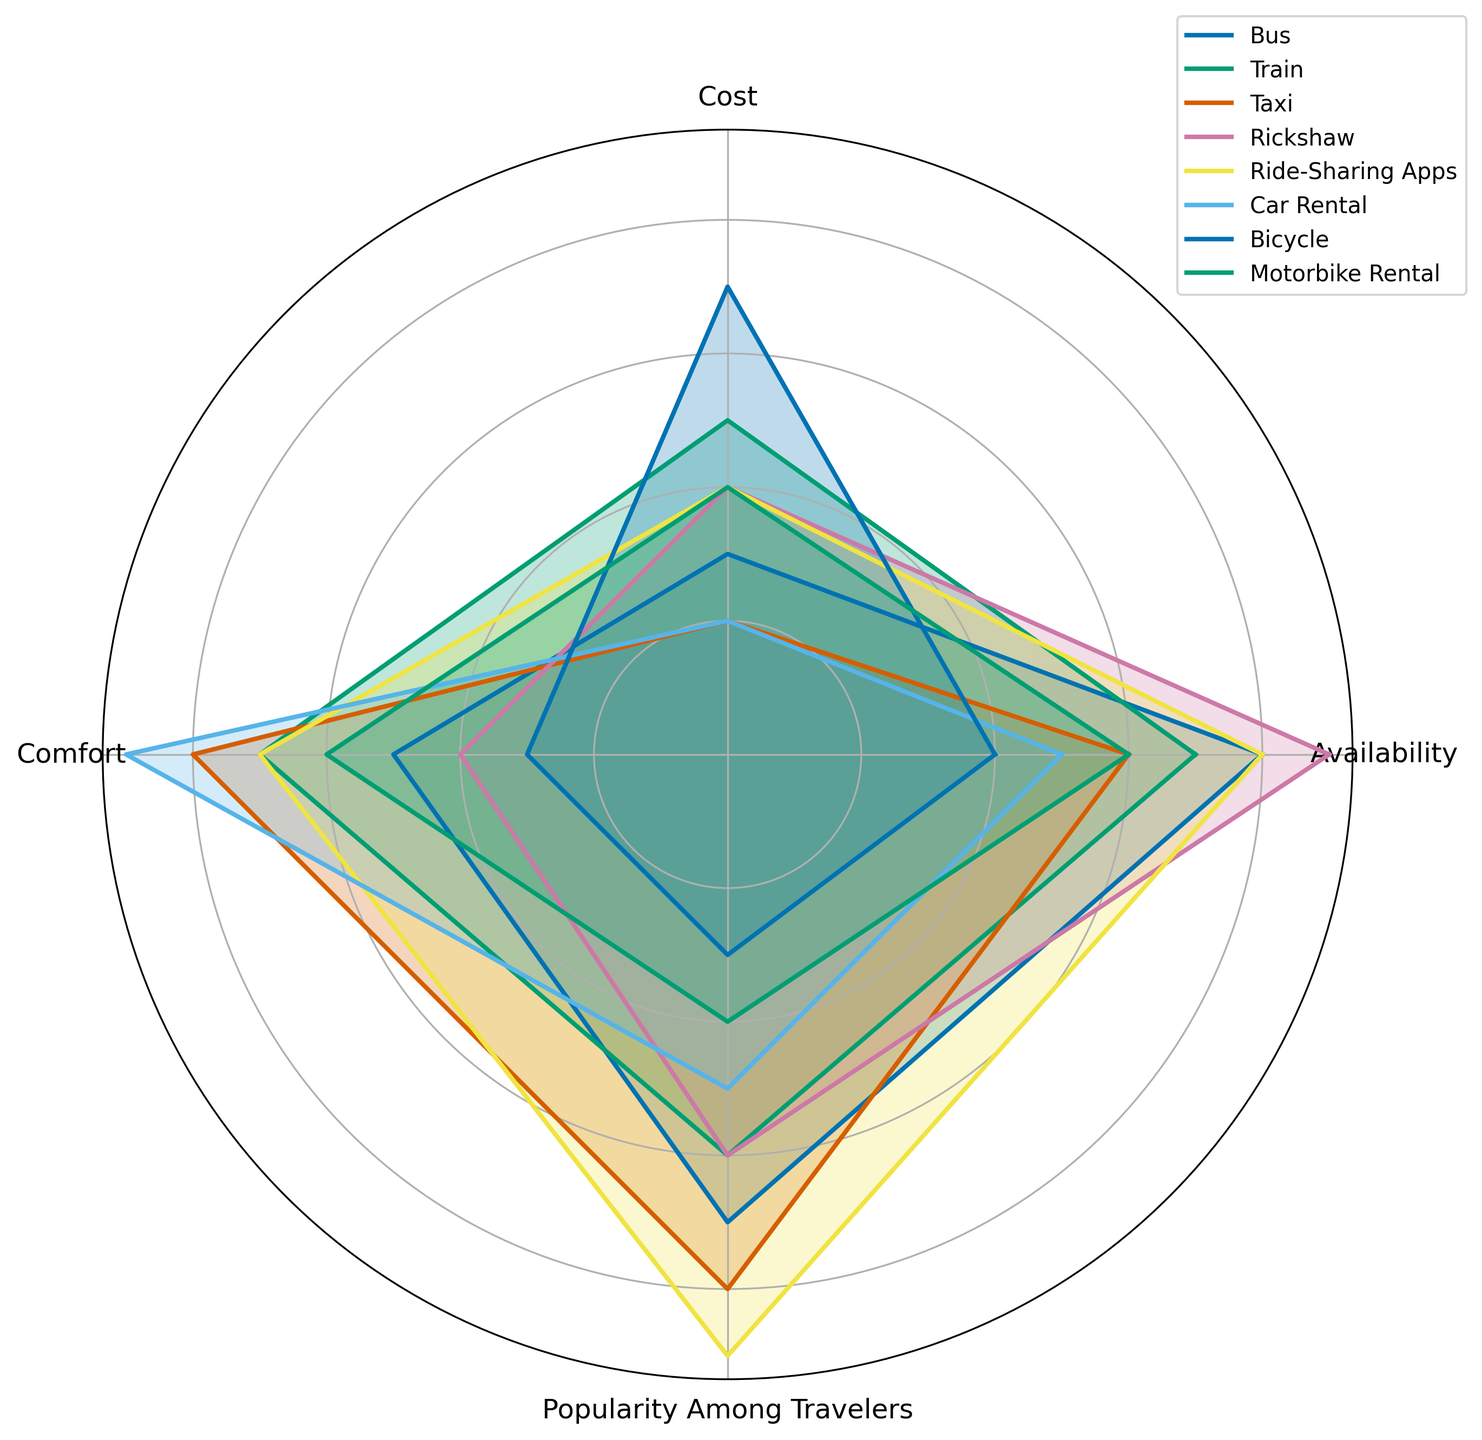Which transportation option is the most popular among travelers? By observing the "Popularity Among Travelers" category, "Ride-Sharing Apps" has the highest value, indicating it's the most popular.
Answer: Ride-Sharing Apps Which transportation options have the lowest cost? By looking at the "Cost" category, both "Taxi" and "Car Rental" have the lowest values, which are equal to 2.
Answer: Taxi, Car Rental What is the average availability of all transportation options? Sum the availability values for all options: (8 + 7 + 6 + 9 + 8 + 5 + 4 + 6) = 53. Then divide by the number of options, 8: 53 / 8 = 6.625.
Answer: 6.625 Between Bus and Train, which is more comfortable? Comparing the "Comfort" values, the Train has a value of 7, while the Bus has a value of 5. Therefore, the Train is more comfortable.
Answer: Train How does the cost of a Rickshaw compare to the cost of using a Bicycle? Observing the "Cost" values, Rickshaw has a value of 4, and Bicycle has a value of 7. The Rickshaw is cheaper than the Bicycle.
Answer: Rickshaw is cheaper than Bicycle Which transportation options have values equal to or greater than 8 in any category? Inspect categories for values equal to or greater than 8: 
- Bus in Availability (8)
- Taxi in Comfort (8)
- Ride-Sharing Apps in Popularity Among Travelers (9) and Comfort (8)
- Car Rental in Comfort (9)
Answer: Bus, Taxi, Ride-Sharing Apps, Car Rental Is Bicycle more popular among travelers than Motorbike Rental? Looking at "Popularity Among Travelers," Bicycle has a value of 3, while Motorbike Rental has a value of 4. Hence, Motorbike Rental is more popular.
Answer: No If you wanted maximum comfort with minimum cost, which option would you choose? For maximum comfort (value 9), Car Rental stands out, but it also has a low cost value of 2, which is nearly minimal.
Answer: Car Rental What's the difference in availability between the most and least available transportation options? The most available option is Rickshaw (9), and the least is Bicycle (4). The difference is: 9 - 4 = 5.
Answer: 5 